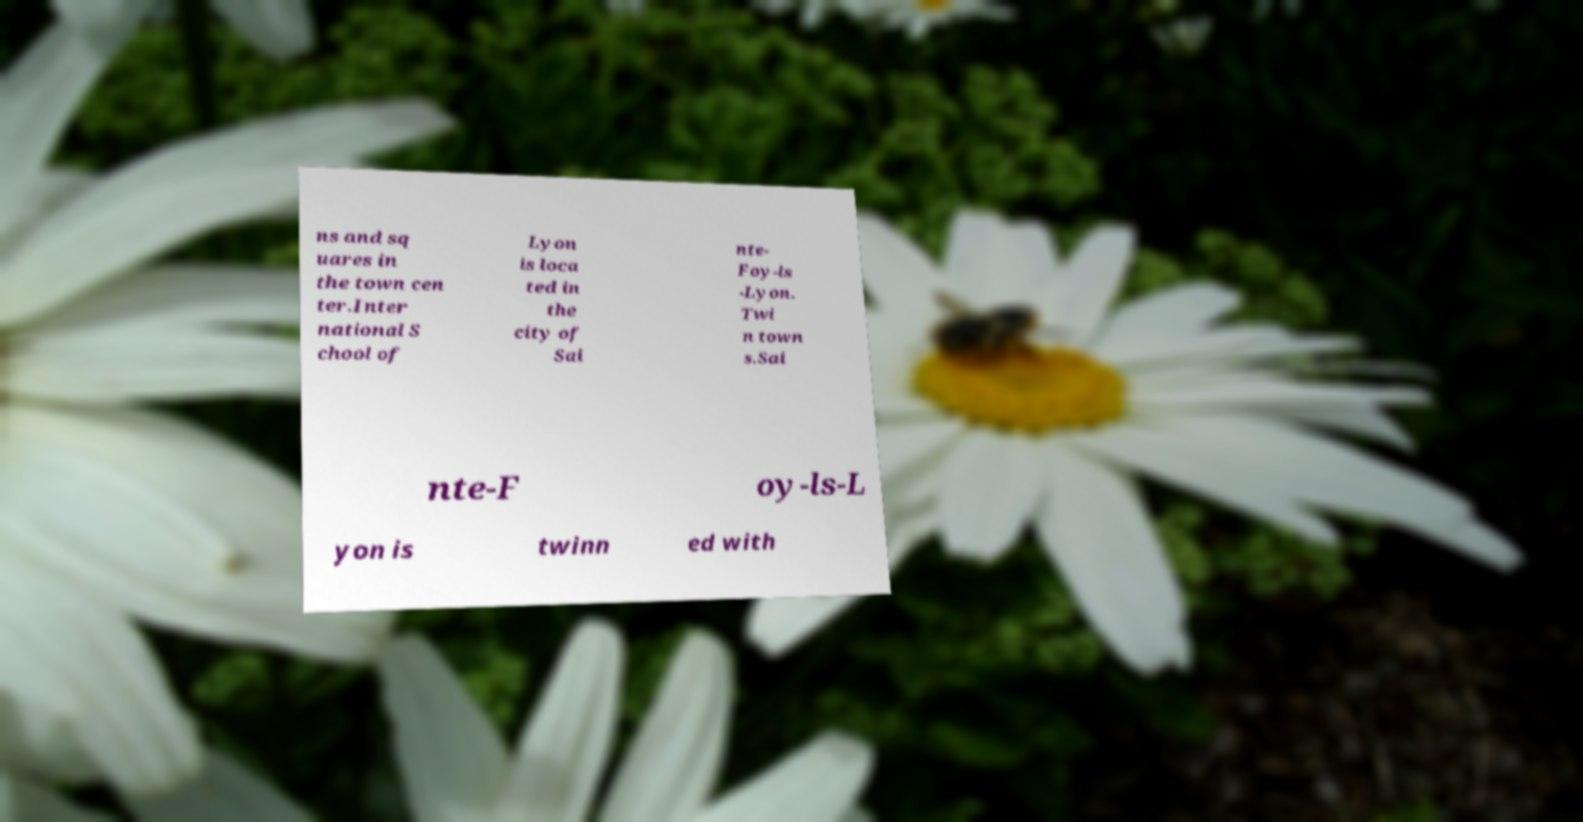What messages or text are displayed in this image? I need them in a readable, typed format. ns and sq uares in the town cen ter.Inter national S chool of Lyon is loca ted in the city of Sai nte- Foy-ls -Lyon. Twi n town s.Sai nte-F oy-ls-L yon is twinn ed with 